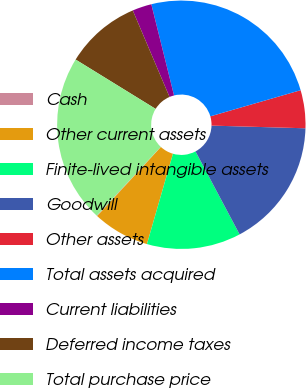Convert chart to OTSL. <chart><loc_0><loc_0><loc_500><loc_500><pie_chart><fcel>Cash<fcel>Other current assets<fcel>Finite-lived intangible assets<fcel>Goodwill<fcel>Other assets<fcel>Total assets acquired<fcel>Current liabilities<fcel>Deferred income taxes<fcel>Total purchase price<nl><fcel>0.08%<fcel>7.38%<fcel>12.24%<fcel>16.77%<fcel>4.94%<fcel>24.4%<fcel>2.51%<fcel>9.81%<fcel>21.87%<nl></chart> 